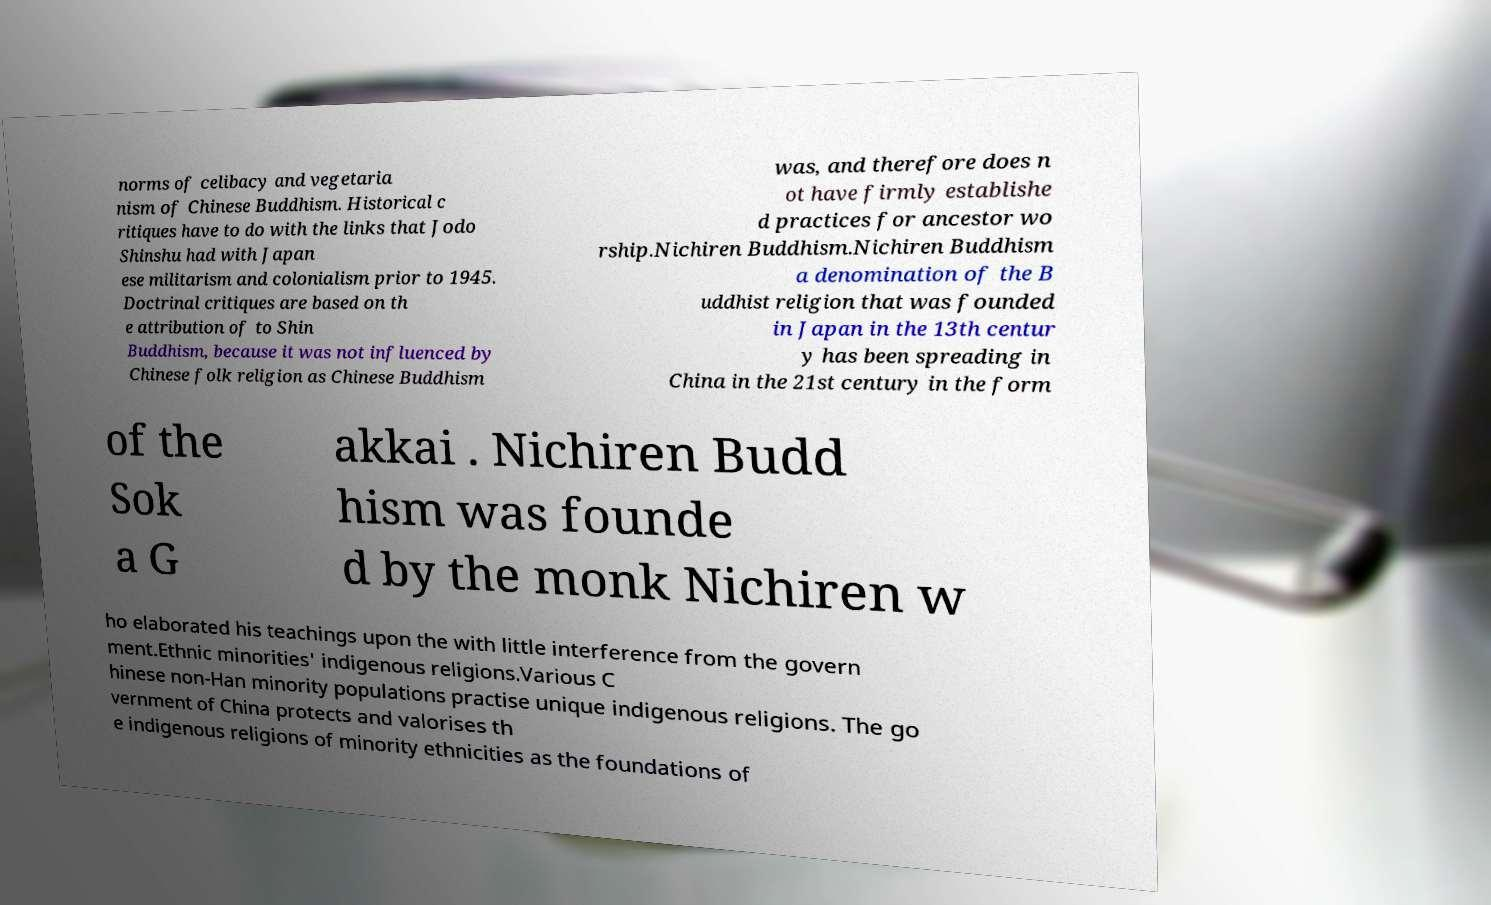Can you accurately transcribe the text from the provided image for me? norms of celibacy and vegetaria nism of Chinese Buddhism. Historical c ritiques have to do with the links that Jodo Shinshu had with Japan ese militarism and colonialism prior to 1945. Doctrinal critiques are based on th e attribution of to Shin Buddhism, because it was not influenced by Chinese folk religion as Chinese Buddhism was, and therefore does n ot have firmly establishe d practices for ancestor wo rship.Nichiren Buddhism.Nichiren Buddhism a denomination of the B uddhist religion that was founded in Japan in the 13th centur y has been spreading in China in the 21st century in the form of the Sok a G akkai . Nichiren Budd hism was founde d by the monk Nichiren w ho elaborated his teachings upon the with little interference from the govern ment.Ethnic minorities' indigenous religions.Various C hinese non-Han minority populations practise unique indigenous religions. The go vernment of China protects and valorises th e indigenous religions of minority ethnicities as the foundations of 